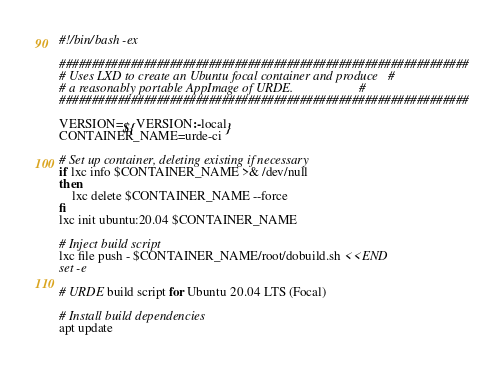<code> <loc_0><loc_0><loc_500><loc_500><_Bash_>#!/bin/bash -ex

###############################################################
# Uses LXD to create an Ubuntu focal container and produce   #
# a reasonably portable AppImage of URDE.                    #
###############################################################

VERSION=${VERSION:-local}
CONTAINER_NAME=urde-ci

# Set up container, deleting existing if necessary
if lxc info $CONTAINER_NAME >& /dev/null
then
    lxc delete $CONTAINER_NAME --force
fi
lxc init ubuntu:20.04 $CONTAINER_NAME

# Inject build script
lxc file push - $CONTAINER_NAME/root/dobuild.sh <<END
set -e

# URDE build script for Ubuntu 20.04 LTS (Focal)

# Install build dependencies
apt update</code> 